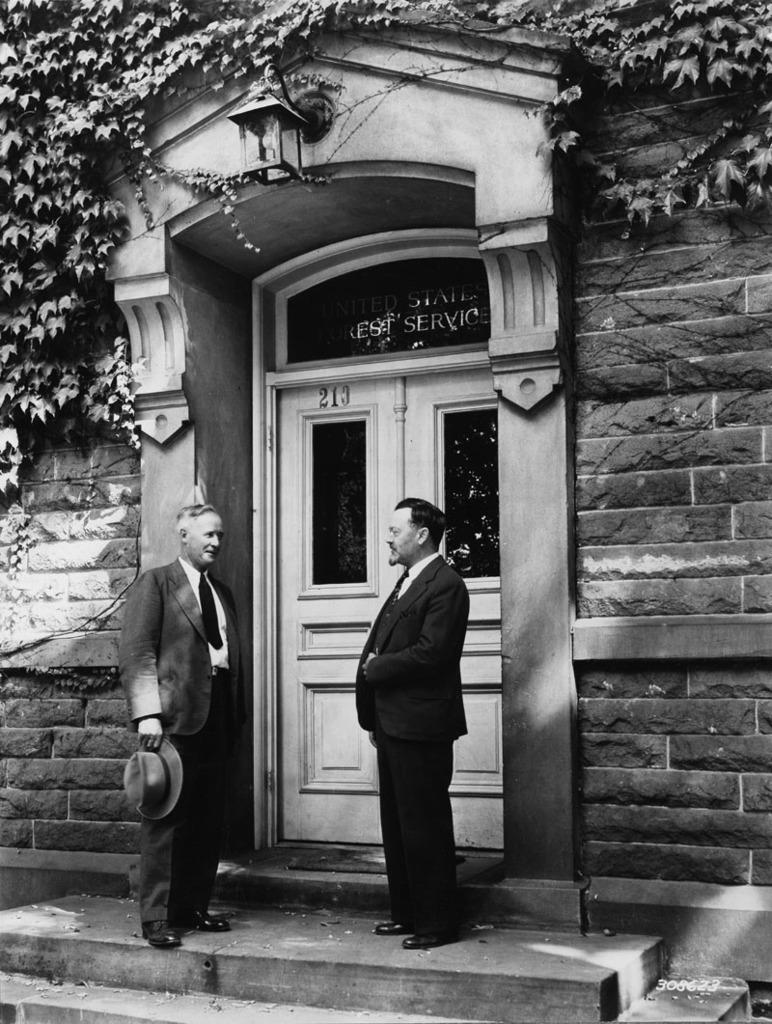In one or two sentences, can you explain what this image depicts? It is a black and white image. In this image we can see the building wall with the door and also leaves and lamp. We can also see two persons wearing the suits and standing on the path. In the bottom right corner we can see the numbers. 